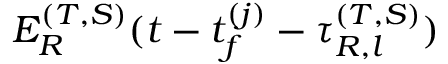<formula> <loc_0><loc_0><loc_500><loc_500>E _ { R } ^ { ( T , S ) } ( t - t _ { f } ^ { ( j ) } - \tau _ { R , l } ^ { ( T , S ) } )</formula> 